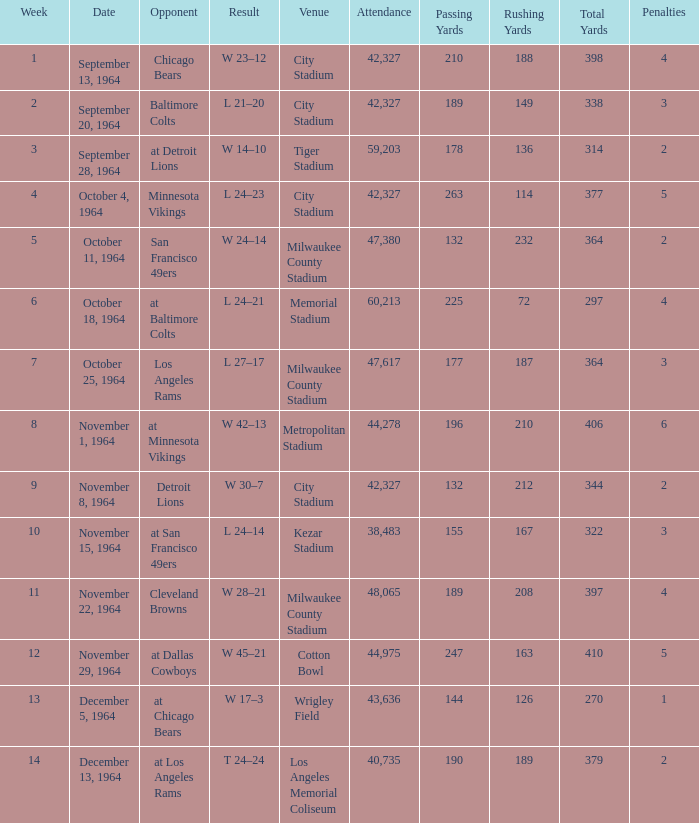Help me parse the entirety of this table. {'header': ['Week', 'Date', 'Opponent', 'Result', 'Venue', 'Attendance', 'Passing Yards', 'Rushing Yards', 'Total Yards', 'Penalties'], 'rows': [['1', 'September 13, 1964', 'Chicago Bears', 'W 23–12', 'City Stadium', '42,327', '210', '188', '398', '4'], ['2', 'September 20, 1964', 'Baltimore Colts', 'L 21–20', 'City Stadium', '42,327', '189', '149', '338', '3'], ['3', 'September 28, 1964', 'at Detroit Lions', 'W 14–10', 'Tiger Stadium', '59,203', '178', '136', '314', '2'], ['4', 'October 4, 1964', 'Minnesota Vikings', 'L 24–23', 'City Stadium', '42,327', '263', '114', '377', '5'], ['5', 'October 11, 1964', 'San Francisco 49ers', 'W 24–14', 'Milwaukee County Stadium', '47,380', '132', '232', '364', '2'], ['6', 'October 18, 1964', 'at Baltimore Colts', 'L 24–21', 'Memorial Stadium', '60,213', '225', '72', '297', '4'], ['7', 'October 25, 1964', 'Los Angeles Rams', 'L 27–17', 'Milwaukee County Stadium', '47,617', '177', '187', '364', '3'], ['8', 'November 1, 1964', 'at Minnesota Vikings', 'W 42–13', 'Metropolitan Stadium', '44,278', '196', '210', '406', '6'], ['9', 'November 8, 1964', 'Detroit Lions', 'W 30–7', 'City Stadium', '42,327', '132', '212', '344', '2'], ['10', 'November 15, 1964', 'at San Francisco 49ers', 'L 24–14', 'Kezar Stadium', '38,483', '155', '167', '322', '3'], ['11', 'November 22, 1964', 'Cleveland Browns', 'W 28–21', 'Milwaukee County Stadium', '48,065', '189', '208', '397', '4'], ['12', 'November 29, 1964', 'at Dallas Cowboys', 'W 45–21', 'Cotton Bowl', '44,975', '247', '163', '410', '5'], ['13', 'December 5, 1964', 'at Chicago Bears', 'W 17–3', 'Wrigley Field', '43,636', '144', '126', '270', '1'], ['14', 'December 13, 1964', 'at Los Angeles Rams', 'T 24–24', 'Los Angeles Memorial Coliseum', '40,735', '190', '189', '379', '2']]} What place accommodated that game with an outcome of 24–14? Kezar Stadium. 